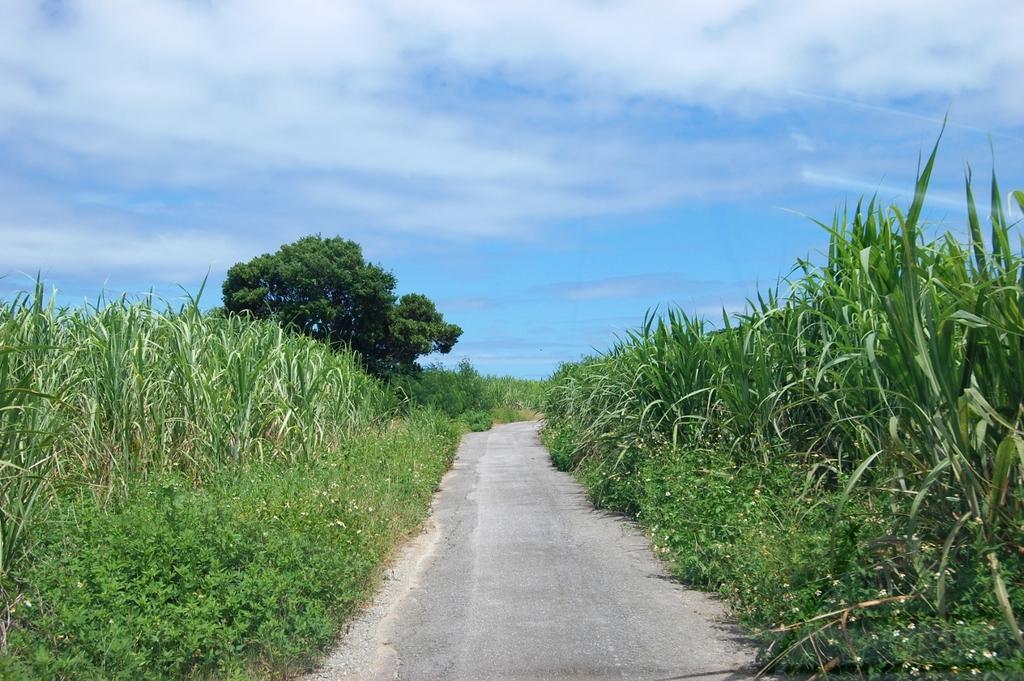In one or two sentences, can you explain what this image depicts? In the foreground I can see plants and trees. At the top I can see the blue sky. This image is taken may be in a farm during a day. 